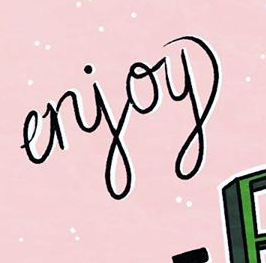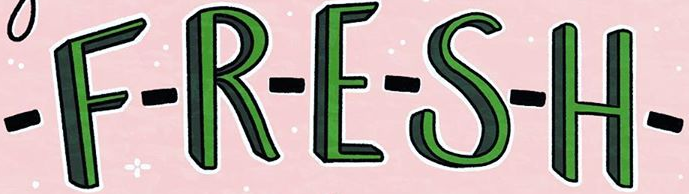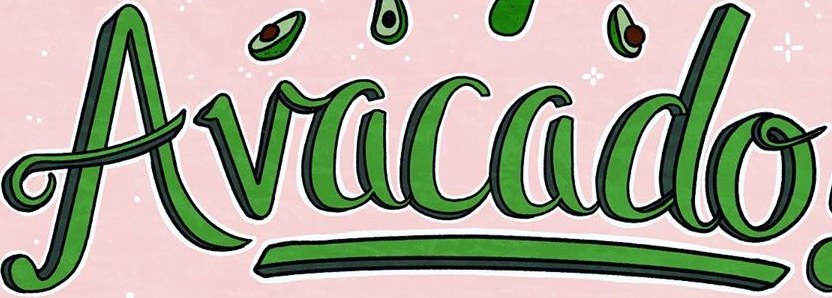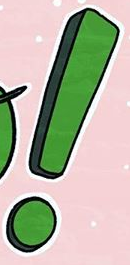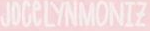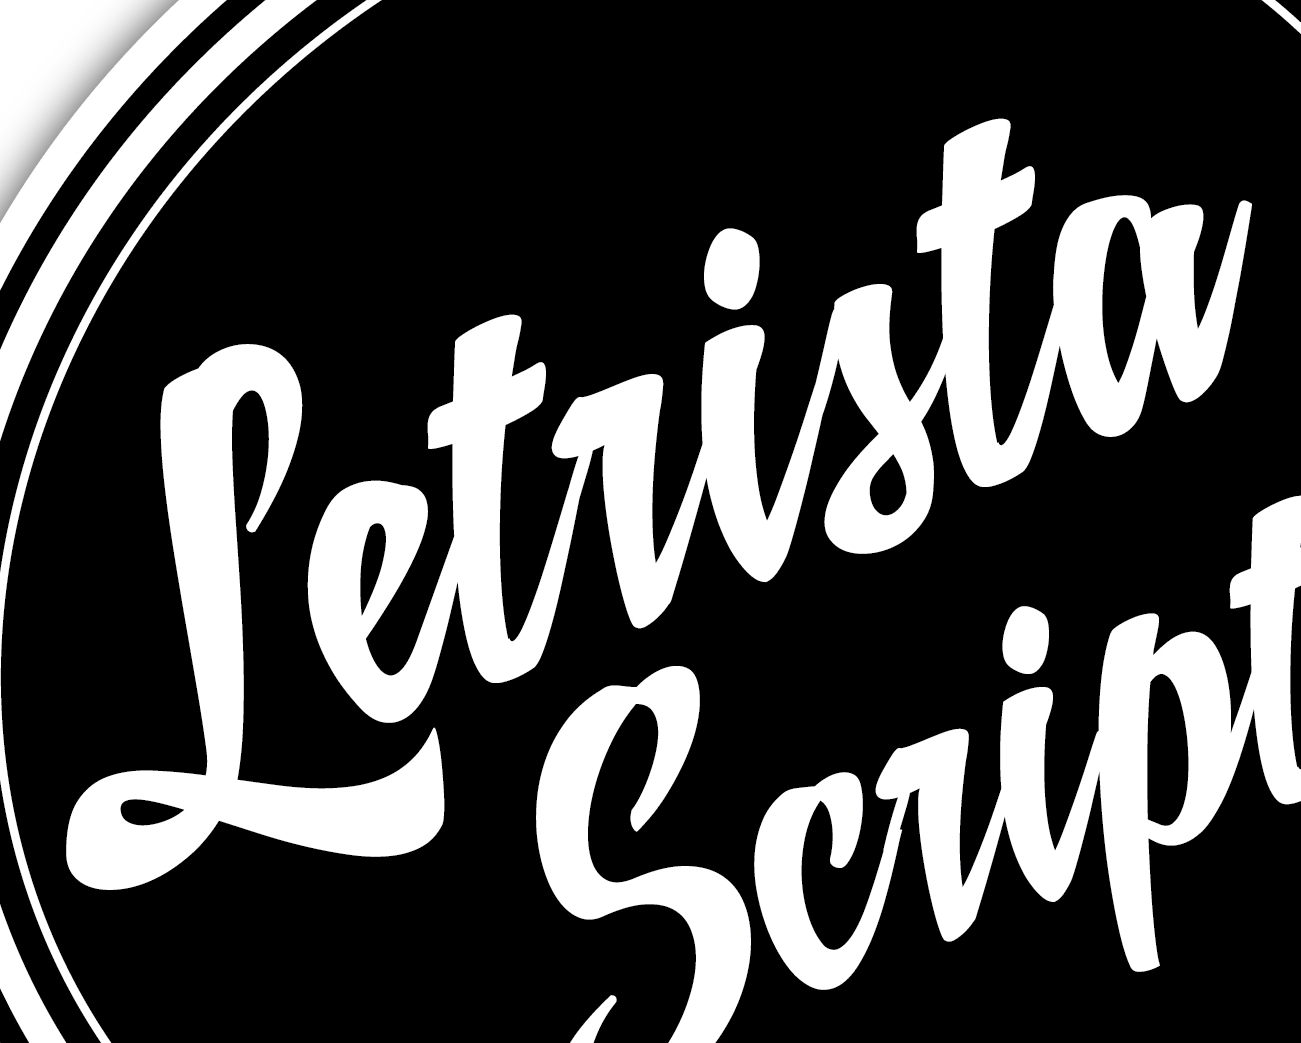What words are shown in these images in order, separated by a semicolon? erjoy; -F-R-E-S-H-; Avacado; !; JOCeLYNMONIZ; Letrista 